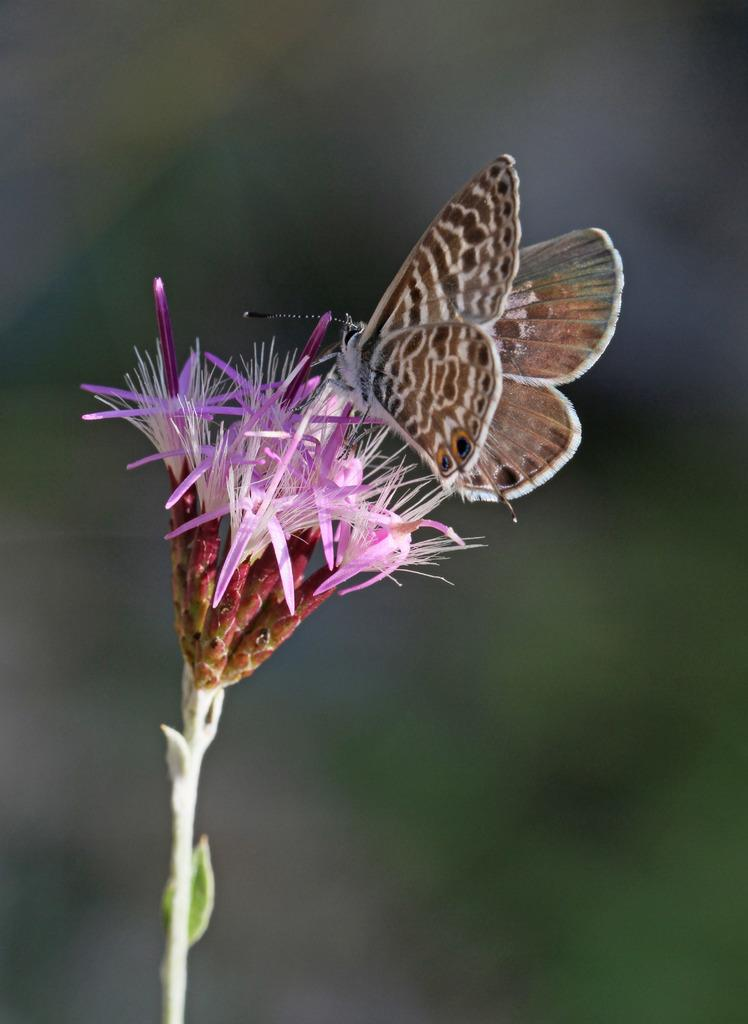What type of insect is in the image? There is a butterfly in the image. What colors can be seen on the butterfly? The butterfly has brown, white, and cream colors. What other living organism is in the image? There is a flower in the image. What colors can be seen on the flower? The flower has pink, cream, red, and white colors. How would you describe the background of the image? The background of the image is blurry. What type of music is being played by the butterfly in the image? There is no music being played in the image; it is a butterfly and a flower in a natural setting. How many cows are visible in the image? There are no cows present in the image. 